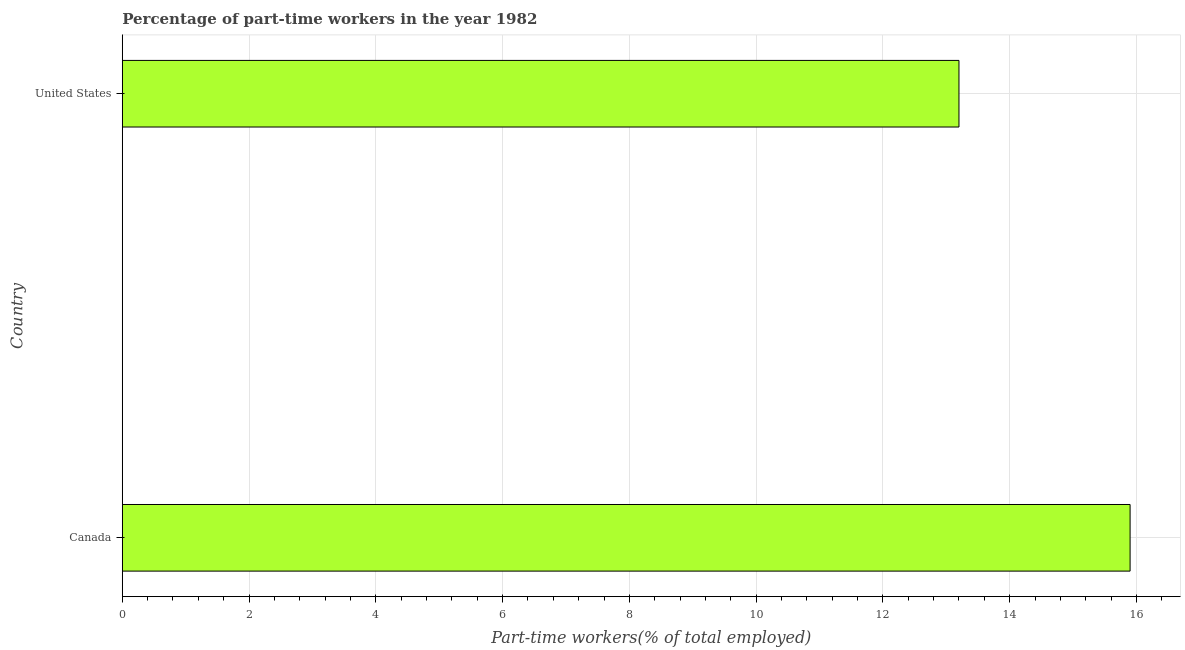Does the graph contain grids?
Give a very brief answer. Yes. What is the title of the graph?
Your answer should be compact. Percentage of part-time workers in the year 1982. What is the label or title of the X-axis?
Offer a terse response. Part-time workers(% of total employed). What is the label or title of the Y-axis?
Give a very brief answer. Country. What is the percentage of part-time workers in Canada?
Ensure brevity in your answer.  15.9. Across all countries, what is the maximum percentage of part-time workers?
Offer a very short reply. 15.9. Across all countries, what is the minimum percentage of part-time workers?
Offer a terse response. 13.2. In which country was the percentage of part-time workers minimum?
Give a very brief answer. United States. What is the sum of the percentage of part-time workers?
Give a very brief answer. 29.1. What is the average percentage of part-time workers per country?
Offer a terse response. 14.55. What is the median percentage of part-time workers?
Your response must be concise. 14.55. In how many countries, is the percentage of part-time workers greater than 14 %?
Provide a succinct answer. 1. What is the ratio of the percentage of part-time workers in Canada to that in United States?
Ensure brevity in your answer.  1.21. Is the percentage of part-time workers in Canada less than that in United States?
Make the answer very short. No. How many bars are there?
Keep it short and to the point. 2. Are all the bars in the graph horizontal?
Offer a terse response. Yes. How many countries are there in the graph?
Ensure brevity in your answer.  2. What is the Part-time workers(% of total employed) of Canada?
Provide a succinct answer. 15.9. What is the Part-time workers(% of total employed) in United States?
Your answer should be compact. 13.2. What is the difference between the Part-time workers(% of total employed) in Canada and United States?
Your answer should be very brief. 2.7. What is the ratio of the Part-time workers(% of total employed) in Canada to that in United States?
Your answer should be compact. 1.21. 